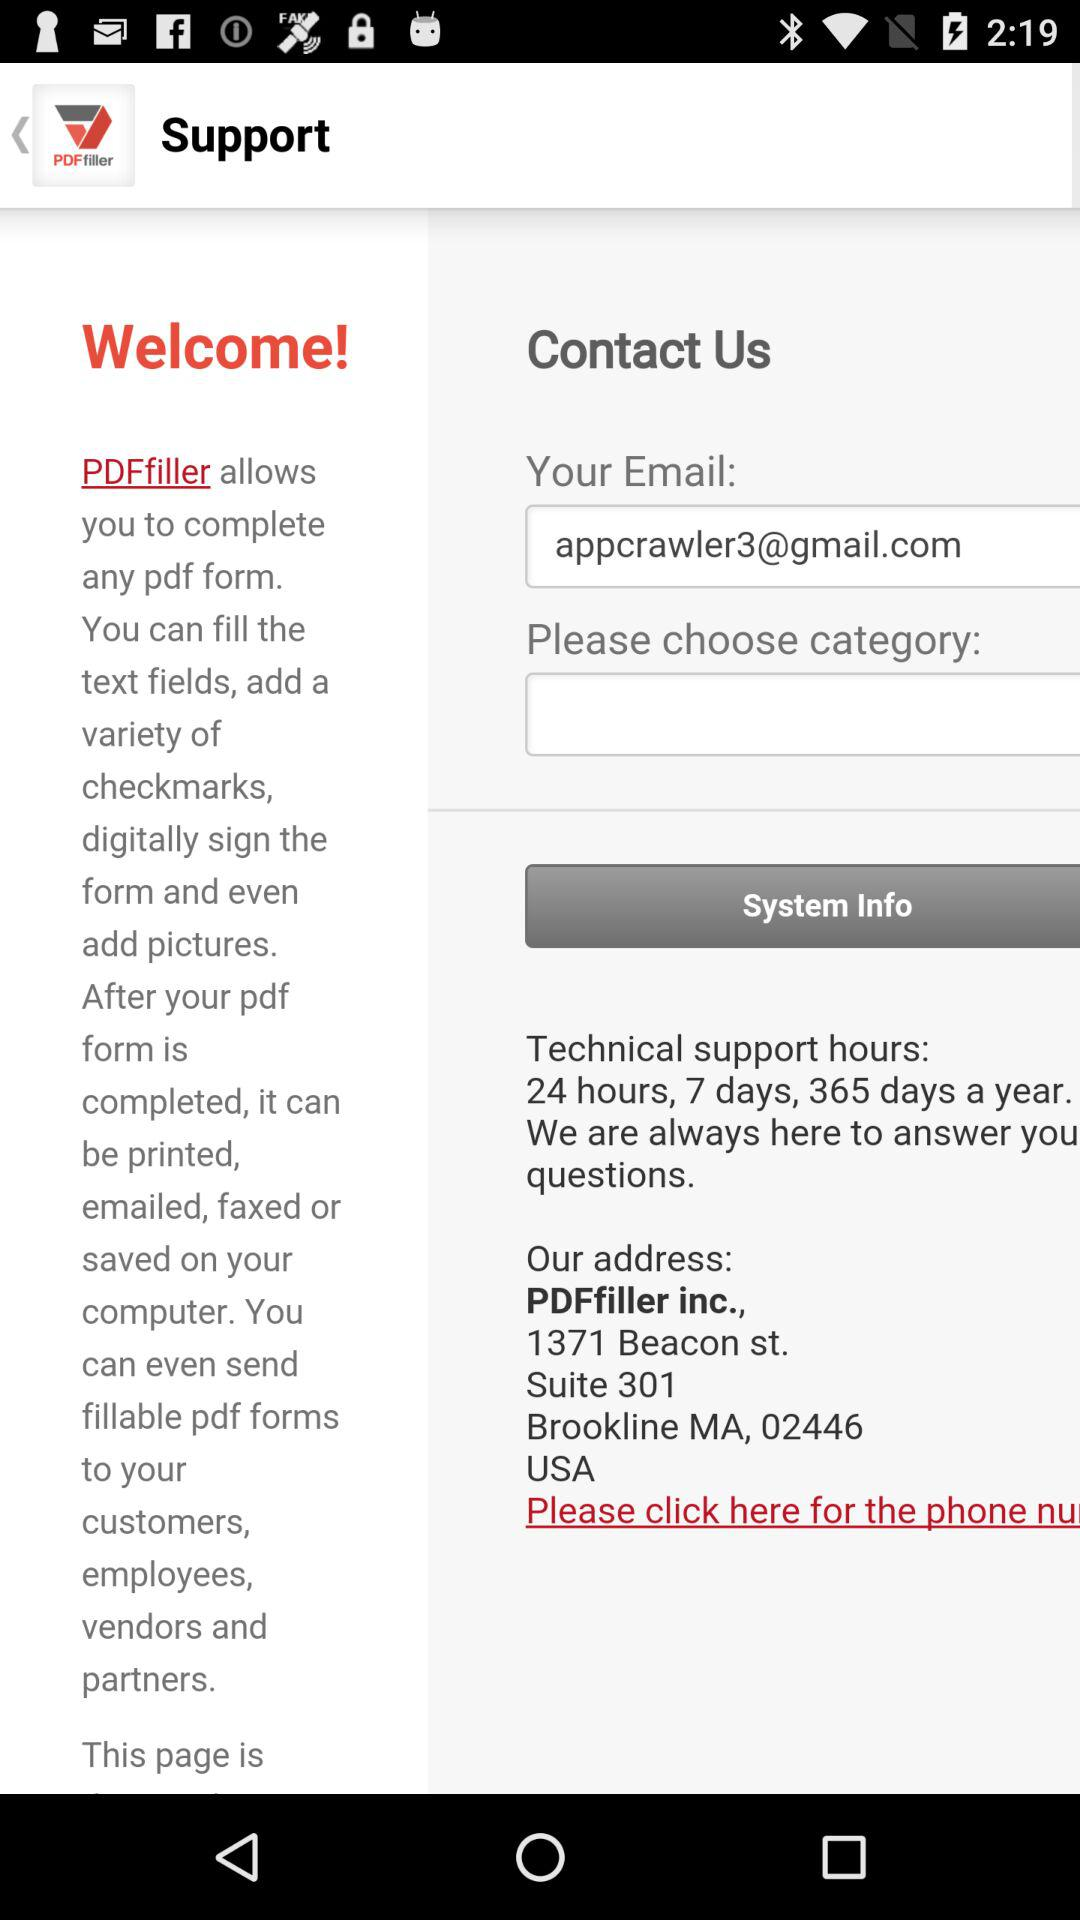What is the provided address? The provided address is PDFfiller inc., 1371 Beacon st., Suite 301 Brookline MA, 02446 USA. 